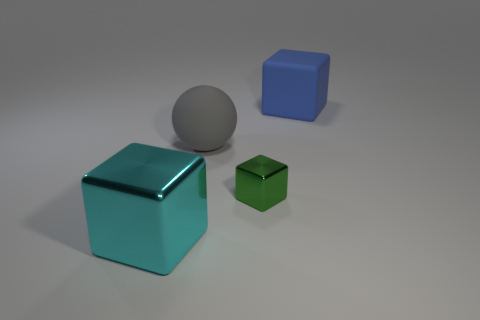Subtract all small green shiny cubes. How many cubes are left? 2 Subtract 2 cubes. How many cubes are left? 1 Add 3 large rubber spheres. How many objects exist? 7 Subtract all cyan metallic cubes. Subtract all big gray spheres. How many objects are left? 2 Add 1 big gray rubber spheres. How many big gray rubber spheres are left? 2 Add 4 blue rubber cubes. How many blue rubber cubes exist? 5 Subtract 0 red cubes. How many objects are left? 4 Subtract all cubes. How many objects are left? 1 Subtract all red spheres. Subtract all blue cylinders. How many spheres are left? 1 